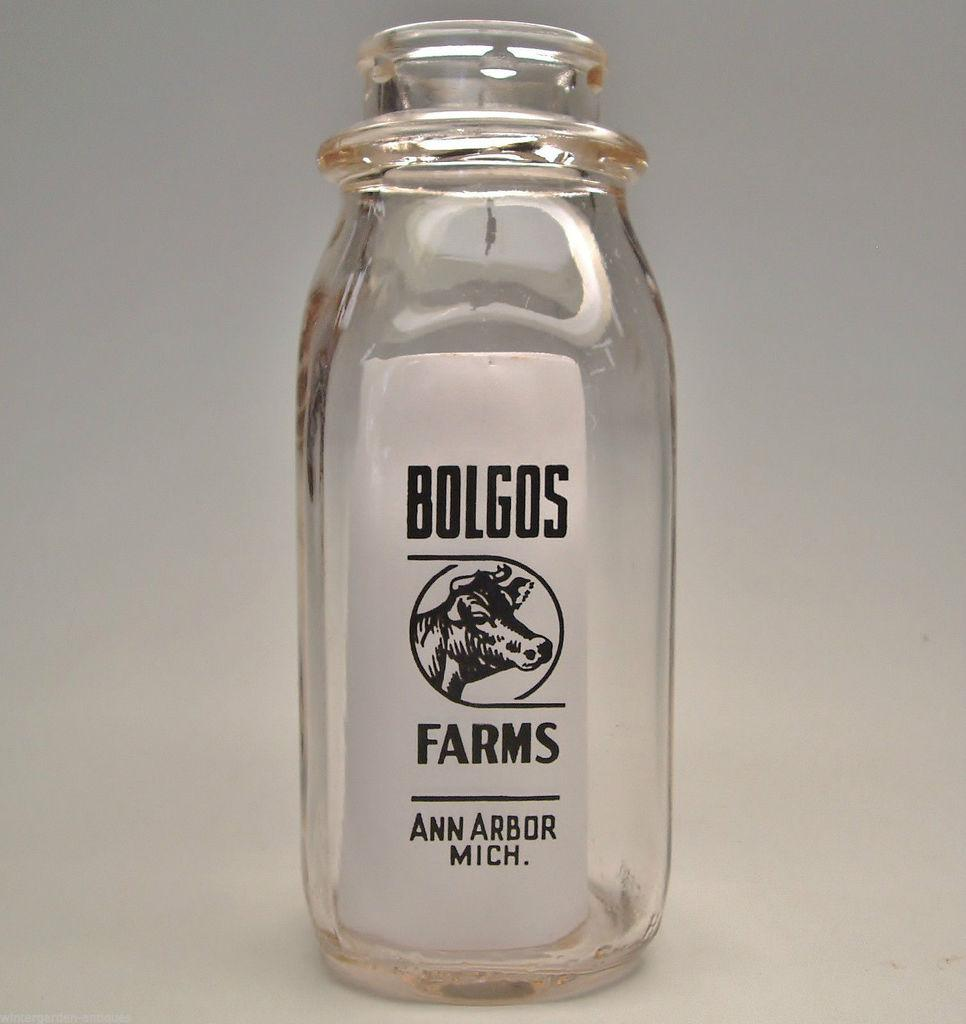<image>
Summarize the visual content of the image. A empty Bolgos Farms bottle sits against a white background 